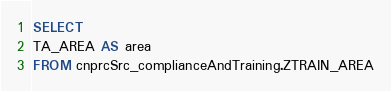Convert code to text. <code><loc_0><loc_0><loc_500><loc_500><_SQL_>SELECT
TA_AREA AS area
FROM cnprcSrc_complianceAndTraining.ZTRAIN_AREA</code> 